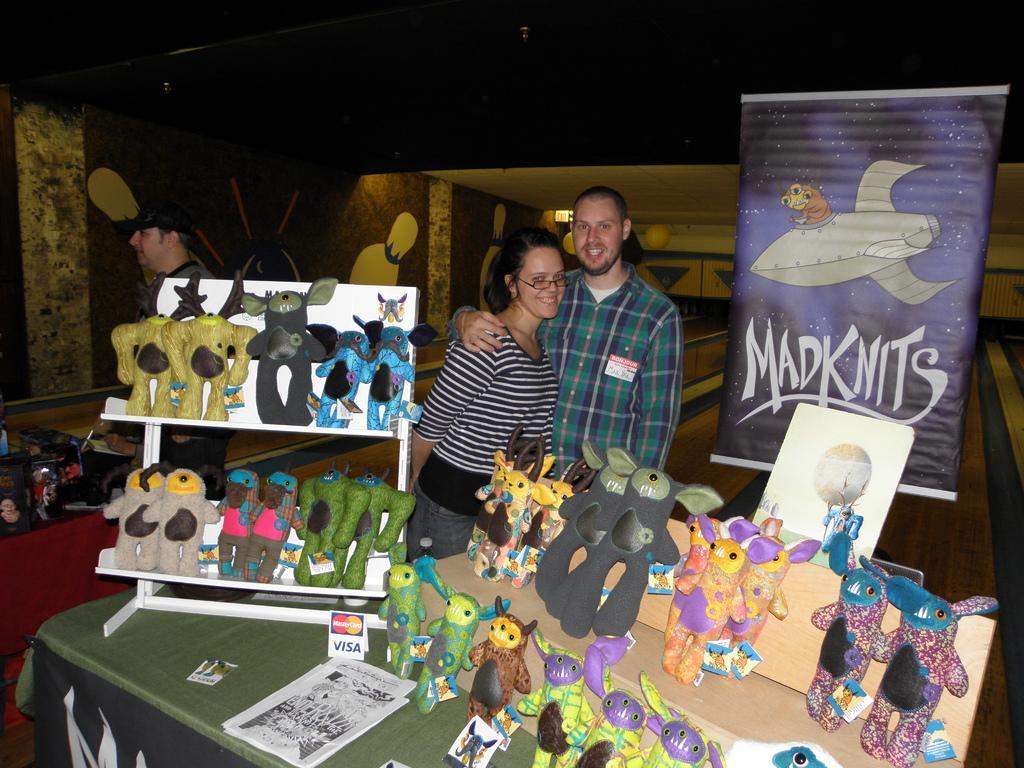Describe this image in one or two sentences. In this image there are two persons. In front on the table there are toys. 